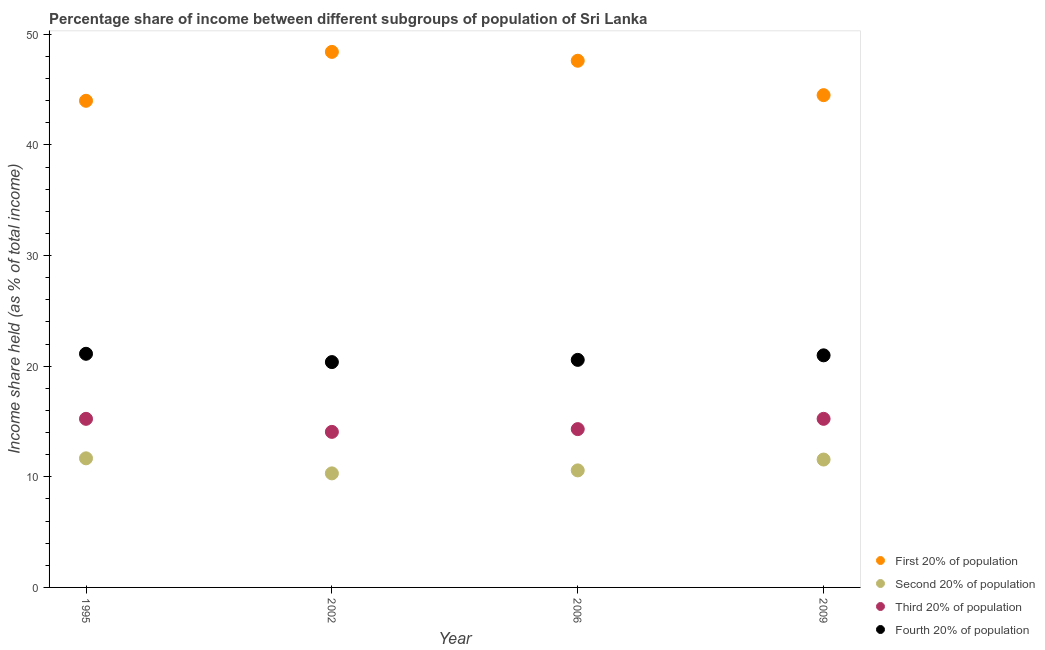How many different coloured dotlines are there?
Your response must be concise. 4. Is the number of dotlines equal to the number of legend labels?
Provide a succinct answer. Yes. What is the share of the income held by first 20% of the population in 2009?
Provide a short and direct response. 44.5. Across all years, what is the maximum share of the income held by fourth 20% of the population?
Your answer should be very brief. 21.12. Across all years, what is the minimum share of the income held by fourth 20% of the population?
Provide a short and direct response. 20.37. In which year was the share of the income held by second 20% of the population maximum?
Make the answer very short. 1995. What is the total share of the income held by first 20% of the population in the graph?
Make the answer very short. 184.51. What is the difference between the share of the income held by third 20% of the population in 1995 and that in 2009?
Make the answer very short. 0. What is the difference between the share of the income held by second 20% of the population in 2006 and the share of the income held by first 20% of the population in 2009?
Give a very brief answer. -33.92. What is the average share of the income held by second 20% of the population per year?
Ensure brevity in your answer.  11.03. In the year 2009, what is the difference between the share of the income held by first 20% of the population and share of the income held by second 20% of the population?
Offer a terse response. 32.94. What is the ratio of the share of the income held by second 20% of the population in 2002 to that in 2006?
Your answer should be very brief. 0.97. Is the share of the income held by first 20% of the population in 2002 less than that in 2009?
Your answer should be compact. No. Is the difference between the share of the income held by second 20% of the population in 2002 and 2006 greater than the difference between the share of the income held by third 20% of the population in 2002 and 2006?
Provide a short and direct response. No. What is the difference between the highest and the second highest share of the income held by third 20% of the population?
Offer a terse response. 0. In how many years, is the share of the income held by second 20% of the population greater than the average share of the income held by second 20% of the population taken over all years?
Provide a short and direct response. 2. Is the sum of the share of the income held by fourth 20% of the population in 2002 and 2006 greater than the maximum share of the income held by first 20% of the population across all years?
Provide a succinct answer. No. Is it the case that in every year, the sum of the share of the income held by third 20% of the population and share of the income held by second 20% of the population is greater than the sum of share of the income held by fourth 20% of the population and share of the income held by first 20% of the population?
Make the answer very short. No. Is it the case that in every year, the sum of the share of the income held by first 20% of the population and share of the income held by second 20% of the population is greater than the share of the income held by third 20% of the population?
Give a very brief answer. Yes. Does the share of the income held by fourth 20% of the population monotonically increase over the years?
Provide a succinct answer. No. Is the share of the income held by second 20% of the population strictly less than the share of the income held by first 20% of the population over the years?
Your answer should be compact. Yes. How many years are there in the graph?
Your answer should be very brief. 4. Where does the legend appear in the graph?
Provide a short and direct response. Bottom right. How are the legend labels stacked?
Ensure brevity in your answer.  Vertical. What is the title of the graph?
Your answer should be very brief. Percentage share of income between different subgroups of population of Sri Lanka. What is the label or title of the X-axis?
Offer a terse response. Year. What is the label or title of the Y-axis?
Provide a succinct answer. Income share held (as % of total income). What is the Income share held (as % of total income) of First 20% of population in 1995?
Your answer should be compact. 43.99. What is the Income share held (as % of total income) in Second 20% of population in 1995?
Provide a succinct answer. 11.67. What is the Income share held (as % of total income) in Third 20% of population in 1995?
Your answer should be very brief. 15.24. What is the Income share held (as % of total income) in Fourth 20% of population in 1995?
Make the answer very short. 21.12. What is the Income share held (as % of total income) in First 20% of population in 2002?
Ensure brevity in your answer.  48.41. What is the Income share held (as % of total income) in Second 20% of population in 2002?
Offer a terse response. 10.31. What is the Income share held (as % of total income) of Third 20% of population in 2002?
Provide a succinct answer. 14.06. What is the Income share held (as % of total income) of Fourth 20% of population in 2002?
Your response must be concise. 20.37. What is the Income share held (as % of total income) of First 20% of population in 2006?
Make the answer very short. 47.61. What is the Income share held (as % of total income) of Second 20% of population in 2006?
Provide a succinct answer. 10.58. What is the Income share held (as % of total income) in Third 20% of population in 2006?
Make the answer very short. 14.31. What is the Income share held (as % of total income) of Fourth 20% of population in 2006?
Keep it short and to the point. 20.57. What is the Income share held (as % of total income) in First 20% of population in 2009?
Give a very brief answer. 44.5. What is the Income share held (as % of total income) in Second 20% of population in 2009?
Your response must be concise. 11.56. What is the Income share held (as % of total income) of Third 20% of population in 2009?
Make the answer very short. 15.24. What is the Income share held (as % of total income) of Fourth 20% of population in 2009?
Give a very brief answer. 20.98. Across all years, what is the maximum Income share held (as % of total income) of First 20% of population?
Keep it short and to the point. 48.41. Across all years, what is the maximum Income share held (as % of total income) of Second 20% of population?
Offer a terse response. 11.67. Across all years, what is the maximum Income share held (as % of total income) in Third 20% of population?
Offer a terse response. 15.24. Across all years, what is the maximum Income share held (as % of total income) of Fourth 20% of population?
Ensure brevity in your answer.  21.12. Across all years, what is the minimum Income share held (as % of total income) of First 20% of population?
Keep it short and to the point. 43.99. Across all years, what is the minimum Income share held (as % of total income) in Second 20% of population?
Provide a succinct answer. 10.31. Across all years, what is the minimum Income share held (as % of total income) of Third 20% of population?
Provide a succinct answer. 14.06. Across all years, what is the minimum Income share held (as % of total income) of Fourth 20% of population?
Give a very brief answer. 20.37. What is the total Income share held (as % of total income) in First 20% of population in the graph?
Your answer should be very brief. 184.51. What is the total Income share held (as % of total income) in Second 20% of population in the graph?
Your answer should be very brief. 44.12. What is the total Income share held (as % of total income) of Third 20% of population in the graph?
Make the answer very short. 58.85. What is the total Income share held (as % of total income) in Fourth 20% of population in the graph?
Offer a terse response. 83.04. What is the difference between the Income share held (as % of total income) of First 20% of population in 1995 and that in 2002?
Ensure brevity in your answer.  -4.42. What is the difference between the Income share held (as % of total income) in Second 20% of population in 1995 and that in 2002?
Your answer should be very brief. 1.36. What is the difference between the Income share held (as % of total income) of Third 20% of population in 1995 and that in 2002?
Keep it short and to the point. 1.18. What is the difference between the Income share held (as % of total income) in First 20% of population in 1995 and that in 2006?
Offer a very short reply. -3.62. What is the difference between the Income share held (as % of total income) of Second 20% of population in 1995 and that in 2006?
Keep it short and to the point. 1.09. What is the difference between the Income share held (as % of total income) of Fourth 20% of population in 1995 and that in 2006?
Keep it short and to the point. 0.55. What is the difference between the Income share held (as % of total income) of First 20% of population in 1995 and that in 2009?
Make the answer very short. -0.51. What is the difference between the Income share held (as % of total income) in Second 20% of population in 1995 and that in 2009?
Offer a very short reply. 0.11. What is the difference between the Income share held (as % of total income) of Fourth 20% of population in 1995 and that in 2009?
Provide a succinct answer. 0.14. What is the difference between the Income share held (as % of total income) of Second 20% of population in 2002 and that in 2006?
Make the answer very short. -0.27. What is the difference between the Income share held (as % of total income) of Third 20% of population in 2002 and that in 2006?
Provide a short and direct response. -0.25. What is the difference between the Income share held (as % of total income) of First 20% of population in 2002 and that in 2009?
Your answer should be compact. 3.91. What is the difference between the Income share held (as % of total income) of Second 20% of population in 2002 and that in 2009?
Provide a short and direct response. -1.25. What is the difference between the Income share held (as % of total income) in Third 20% of population in 2002 and that in 2009?
Keep it short and to the point. -1.18. What is the difference between the Income share held (as % of total income) in Fourth 20% of population in 2002 and that in 2009?
Give a very brief answer. -0.61. What is the difference between the Income share held (as % of total income) of First 20% of population in 2006 and that in 2009?
Provide a short and direct response. 3.11. What is the difference between the Income share held (as % of total income) in Second 20% of population in 2006 and that in 2009?
Keep it short and to the point. -0.98. What is the difference between the Income share held (as % of total income) in Third 20% of population in 2006 and that in 2009?
Your answer should be compact. -0.93. What is the difference between the Income share held (as % of total income) in Fourth 20% of population in 2006 and that in 2009?
Offer a terse response. -0.41. What is the difference between the Income share held (as % of total income) in First 20% of population in 1995 and the Income share held (as % of total income) in Second 20% of population in 2002?
Provide a succinct answer. 33.68. What is the difference between the Income share held (as % of total income) of First 20% of population in 1995 and the Income share held (as % of total income) of Third 20% of population in 2002?
Your answer should be very brief. 29.93. What is the difference between the Income share held (as % of total income) of First 20% of population in 1995 and the Income share held (as % of total income) of Fourth 20% of population in 2002?
Provide a short and direct response. 23.62. What is the difference between the Income share held (as % of total income) of Second 20% of population in 1995 and the Income share held (as % of total income) of Third 20% of population in 2002?
Ensure brevity in your answer.  -2.39. What is the difference between the Income share held (as % of total income) in Second 20% of population in 1995 and the Income share held (as % of total income) in Fourth 20% of population in 2002?
Your response must be concise. -8.7. What is the difference between the Income share held (as % of total income) in Third 20% of population in 1995 and the Income share held (as % of total income) in Fourth 20% of population in 2002?
Keep it short and to the point. -5.13. What is the difference between the Income share held (as % of total income) in First 20% of population in 1995 and the Income share held (as % of total income) in Second 20% of population in 2006?
Keep it short and to the point. 33.41. What is the difference between the Income share held (as % of total income) of First 20% of population in 1995 and the Income share held (as % of total income) of Third 20% of population in 2006?
Keep it short and to the point. 29.68. What is the difference between the Income share held (as % of total income) of First 20% of population in 1995 and the Income share held (as % of total income) of Fourth 20% of population in 2006?
Offer a very short reply. 23.42. What is the difference between the Income share held (as % of total income) in Second 20% of population in 1995 and the Income share held (as % of total income) in Third 20% of population in 2006?
Ensure brevity in your answer.  -2.64. What is the difference between the Income share held (as % of total income) of Second 20% of population in 1995 and the Income share held (as % of total income) of Fourth 20% of population in 2006?
Provide a succinct answer. -8.9. What is the difference between the Income share held (as % of total income) of Third 20% of population in 1995 and the Income share held (as % of total income) of Fourth 20% of population in 2006?
Offer a terse response. -5.33. What is the difference between the Income share held (as % of total income) of First 20% of population in 1995 and the Income share held (as % of total income) of Second 20% of population in 2009?
Provide a short and direct response. 32.43. What is the difference between the Income share held (as % of total income) in First 20% of population in 1995 and the Income share held (as % of total income) in Third 20% of population in 2009?
Keep it short and to the point. 28.75. What is the difference between the Income share held (as % of total income) of First 20% of population in 1995 and the Income share held (as % of total income) of Fourth 20% of population in 2009?
Provide a short and direct response. 23.01. What is the difference between the Income share held (as % of total income) in Second 20% of population in 1995 and the Income share held (as % of total income) in Third 20% of population in 2009?
Offer a very short reply. -3.57. What is the difference between the Income share held (as % of total income) in Second 20% of population in 1995 and the Income share held (as % of total income) in Fourth 20% of population in 2009?
Keep it short and to the point. -9.31. What is the difference between the Income share held (as % of total income) of Third 20% of population in 1995 and the Income share held (as % of total income) of Fourth 20% of population in 2009?
Your answer should be compact. -5.74. What is the difference between the Income share held (as % of total income) of First 20% of population in 2002 and the Income share held (as % of total income) of Second 20% of population in 2006?
Keep it short and to the point. 37.83. What is the difference between the Income share held (as % of total income) in First 20% of population in 2002 and the Income share held (as % of total income) in Third 20% of population in 2006?
Make the answer very short. 34.1. What is the difference between the Income share held (as % of total income) in First 20% of population in 2002 and the Income share held (as % of total income) in Fourth 20% of population in 2006?
Your response must be concise. 27.84. What is the difference between the Income share held (as % of total income) in Second 20% of population in 2002 and the Income share held (as % of total income) in Fourth 20% of population in 2006?
Provide a succinct answer. -10.26. What is the difference between the Income share held (as % of total income) in Third 20% of population in 2002 and the Income share held (as % of total income) in Fourth 20% of population in 2006?
Your answer should be compact. -6.51. What is the difference between the Income share held (as % of total income) in First 20% of population in 2002 and the Income share held (as % of total income) in Second 20% of population in 2009?
Your answer should be very brief. 36.85. What is the difference between the Income share held (as % of total income) of First 20% of population in 2002 and the Income share held (as % of total income) of Third 20% of population in 2009?
Give a very brief answer. 33.17. What is the difference between the Income share held (as % of total income) of First 20% of population in 2002 and the Income share held (as % of total income) of Fourth 20% of population in 2009?
Keep it short and to the point. 27.43. What is the difference between the Income share held (as % of total income) of Second 20% of population in 2002 and the Income share held (as % of total income) of Third 20% of population in 2009?
Offer a very short reply. -4.93. What is the difference between the Income share held (as % of total income) in Second 20% of population in 2002 and the Income share held (as % of total income) in Fourth 20% of population in 2009?
Provide a succinct answer. -10.67. What is the difference between the Income share held (as % of total income) of Third 20% of population in 2002 and the Income share held (as % of total income) of Fourth 20% of population in 2009?
Offer a very short reply. -6.92. What is the difference between the Income share held (as % of total income) of First 20% of population in 2006 and the Income share held (as % of total income) of Second 20% of population in 2009?
Keep it short and to the point. 36.05. What is the difference between the Income share held (as % of total income) in First 20% of population in 2006 and the Income share held (as % of total income) in Third 20% of population in 2009?
Keep it short and to the point. 32.37. What is the difference between the Income share held (as % of total income) of First 20% of population in 2006 and the Income share held (as % of total income) of Fourth 20% of population in 2009?
Your answer should be compact. 26.63. What is the difference between the Income share held (as % of total income) in Second 20% of population in 2006 and the Income share held (as % of total income) in Third 20% of population in 2009?
Your answer should be very brief. -4.66. What is the difference between the Income share held (as % of total income) of Second 20% of population in 2006 and the Income share held (as % of total income) of Fourth 20% of population in 2009?
Give a very brief answer. -10.4. What is the difference between the Income share held (as % of total income) in Third 20% of population in 2006 and the Income share held (as % of total income) in Fourth 20% of population in 2009?
Provide a short and direct response. -6.67. What is the average Income share held (as % of total income) of First 20% of population per year?
Provide a short and direct response. 46.13. What is the average Income share held (as % of total income) in Second 20% of population per year?
Provide a short and direct response. 11.03. What is the average Income share held (as % of total income) in Third 20% of population per year?
Ensure brevity in your answer.  14.71. What is the average Income share held (as % of total income) in Fourth 20% of population per year?
Offer a very short reply. 20.76. In the year 1995, what is the difference between the Income share held (as % of total income) in First 20% of population and Income share held (as % of total income) in Second 20% of population?
Offer a very short reply. 32.32. In the year 1995, what is the difference between the Income share held (as % of total income) of First 20% of population and Income share held (as % of total income) of Third 20% of population?
Provide a short and direct response. 28.75. In the year 1995, what is the difference between the Income share held (as % of total income) in First 20% of population and Income share held (as % of total income) in Fourth 20% of population?
Provide a short and direct response. 22.87. In the year 1995, what is the difference between the Income share held (as % of total income) of Second 20% of population and Income share held (as % of total income) of Third 20% of population?
Offer a terse response. -3.57. In the year 1995, what is the difference between the Income share held (as % of total income) in Second 20% of population and Income share held (as % of total income) in Fourth 20% of population?
Your answer should be compact. -9.45. In the year 1995, what is the difference between the Income share held (as % of total income) of Third 20% of population and Income share held (as % of total income) of Fourth 20% of population?
Ensure brevity in your answer.  -5.88. In the year 2002, what is the difference between the Income share held (as % of total income) in First 20% of population and Income share held (as % of total income) in Second 20% of population?
Provide a short and direct response. 38.1. In the year 2002, what is the difference between the Income share held (as % of total income) of First 20% of population and Income share held (as % of total income) of Third 20% of population?
Give a very brief answer. 34.35. In the year 2002, what is the difference between the Income share held (as % of total income) in First 20% of population and Income share held (as % of total income) in Fourth 20% of population?
Provide a succinct answer. 28.04. In the year 2002, what is the difference between the Income share held (as % of total income) in Second 20% of population and Income share held (as % of total income) in Third 20% of population?
Your answer should be very brief. -3.75. In the year 2002, what is the difference between the Income share held (as % of total income) of Second 20% of population and Income share held (as % of total income) of Fourth 20% of population?
Ensure brevity in your answer.  -10.06. In the year 2002, what is the difference between the Income share held (as % of total income) in Third 20% of population and Income share held (as % of total income) in Fourth 20% of population?
Provide a short and direct response. -6.31. In the year 2006, what is the difference between the Income share held (as % of total income) in First 20% of population and Income share held (as % of total income) in Second 20% of population?
Ensure brevity in your answer.  37.03. In the year 2006, what is the difference between the Income share held (as % of total income) in First 20% of population and Income share held (as % of total income) in Third 20% of population?
Keep it short and to the point. 33.3. In the year 2006, what is the difference between the Income share held (as % of total income) of First 20% of population and Income share held (as % of total income) of Fourth 20% of population?
Your answer should be compact. 27.04. In the year 2006, what is the difference between the Income share held (as % of total income) in Second 20% of population and Income share held (as % of total income) in Third 20% of population?
Your answer should be compact. -3.73. In the year 2006, what is the difference between the Income share held (as % of total income) in Second 20% of population and Income share held (as % of total income) in Fourth 20% of population?
Keep it short and to the point. -9.99. In the year 2006, what is the difference between the Income share held (as % of total income) in Third 20% of population and Income share held (as % of total income) in Fourth 20% of population?
Ensure brevity in your answer.  -6.26. In the year 2009, what is the difference between the Income share held (as % of total income) of First 20% of population and Income share held (as % of total income) of Second 20% of population?
Your answer should be compact. 32.94. In the year 2009, what is the difference between the Income share held (as % of total income) in First 20% of population and Income share held (as % of total income) in Third 20% of population?
Your response must be concise. 29.26. In the year 2009, what is the difference between the Income share held (as % of total income) in First 20% of population and Income share held (as % of total income) in Fourth 20% of population?
Ensure brevity in your answer.  23.52. In the year 2009, what is the difference between the Income share held (as % of total income) in Second 20% of population and Income share held (as % of total income) in Third 20% of population?
Your answer should be very brief. -3.68. In the year 2009, what is the difference between the Income share held (as % of total income) in Second 20% of population and Income share held (as % of total income) in Fourth 20% of population?
Give a very brief answer. -9.42. In the year 2009, what is the difference between the Income share held (as % of total income) of Third 20% of population and Income share held (as % of total income) of Fourth 20% of population?
Your answer should be very brief. -5.74. What is the ratio of the Income share held (as % of total income) in First 20% of population in 1995 to that in 2002?
Provide a succinct answer. 0.91. What is the ratio of the Income share held (as % of total income) in Second 20% of population in 1995 to that in 2002?
Offer a terse response. 1.13. What is the ratio of the Income share held (as % of total income) in Third 20% of population in 1995 to that in 2002?
Provide a short and direct response. 1.08. What is the ratio of the Income share held (as % of total income) in Fourth 20% of population in 1995 to that in 2002?
Offer a terse response. 1.04. What is the ratio of the Income share held (as % of total income) in First 20% of population in 1995 to that in 2006?
Your answer should be very brief. 0.92. What is the ratio of the Income share held (as % of total income) in Second 20% of population in 1995 to that in 2006?
Your response must be concise. 1.1. What is the ratio of the Income share held (as % of total income) in Third 20% of population in 1995 to that in 2006?
Give a very brief answer. 1.06. What is the ratio of the Income share held (as % of total income) of Fourth 20% of population in 1995 to that in 2006?
Ensure brevity in your answer.  1.03. What is the ratio of the Income share held (as % of total income) in First 20% of population in 1995 to that in 2009?
Keep it short and to the point. 0.99. What is the ratio of the Income share held (as % of total income) of Second 20% of population in 1995 to that in 2009?
Give a very brief answer. 1.01. What is the ratio of the Income share held (as % of total income) in First 20% of population in 2002 to that in 2006?
Offer a terse response. 1.02. What is the ratio of the Income share held (as % of total income) in Second 20% of population in 2002 to that in 2006?
Provide a succinct answer. 0.97. What is the ratio of the Income share held (as % of total income) in Third 20% of population in 2002 to that in 2006?
Your answer should be very brief. 0.98. What is the ratio of the Income share held (as % of total income) in Fourth 20% of population in 2002 to that in 2006?
Offer a terse response. 0.99. What is the ratio of the Income share held (as % of total income) in First 20% of population in 2002 to that in 2009?
Your answer should be very brief. 1.09. What is the ratio of the Income share held (as % of total income) in Second 20% of population in 2002 to that in 2009?
Ensure brevity in your answer.  0.89. What is the ratio of the Income share held (as % of total income) in Third 20% of population in 2002 to that in 2009?
Give a very brief answer. 0.92. What is the ratio of the Income share held (as % of total income) in Fourth 20% of population in 2002 to that in 2009?
Provide a succinct answer. 0.97. What is the ratio of the Income share held (as % of total income) in First 20% of population in 2006 to that in 2009?
Your answer should be very brief. 1.07. What is the ratio of the Income share held (as % of total income) in Second 20% of population in 2006 to that in 2009?
Give a very brief answer. 0.92. What is the ratio of the Income share held (as % of total income) in Third 20% of population in 2006 to that in 2009?
Your response must be concise. 0.94. What is the ratio of the Income share held (as % of total income) in Fourth 20% of population in 2006 to that in 2009?
Offer a very short reply. 0.98. What is the difference between the highest and the second highest Income share held (as % of total income) in Second 20% of population?
Ensure brevity in your answer.  0.11. What is the difference between the highest and the second highest Income share held (as % of total income) of Third 20% of population?
Give a very brief answer. 0. What is the difference between the highest and the second highest Income share held (as % of total income) of Fourth 20% of population?
Ensure brevity in your answer.  0.14. What is the difference between the highest and the lowest Income share held (as % of total income) in First 20% of population?
Ensure brevity in your answer.  4.42. What is the difference between the highest and the lowest Income share held (as % of total income) in Second 20% of population?
Provide a succinct answer. 1.36. What is the difference between the highest and the lowest Income share held (as % of total income) of Third 20% of population?
Make the answer very short. 1.18. What is the difference between the highest and the lowest Income share held (as % of total income) of Fourth 20% of population?
Your answer should be very brief. 0.75. 